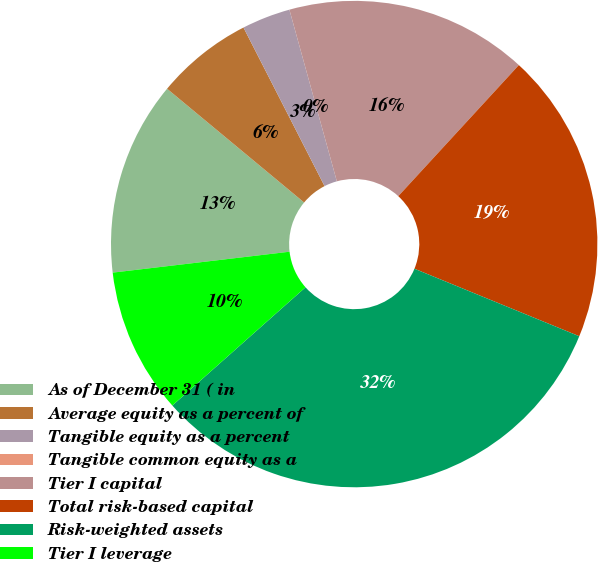Convert chart to OTSL. <chart><loc_0><loc_0><loc_500><loc_500><pie_chart><fcel>As of December 31 ( in<fcel>Average equity as a percent of<fcel>Tangible equity as a percent<fcel>Tangible common equity as a<fcel>Tier I capital<fcel>Total risk-based capital<fcel>Risk-weighted assets<fcel>Tier I leverage<nl><fcel>12.9%<fcel>6.45%<fcel>3.23%<fcel>0.0%<fcel>16.13%<fcel>19.35%<fcel>32.26%<fcel>9.68%<nl></chart> 